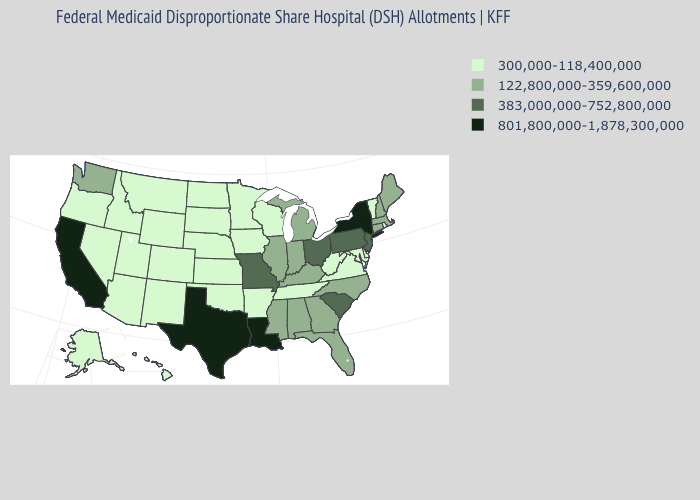Name the states that have a value in the range 122,800,000-359,600,000?
Be succinct. Alabama, Connecticut, Florida, Georgia, Illinois, Indiana, Kentucky, Maine, Massachusetts, Michigan, Mississippi, New Hampshire, North Carolina, Washington. Name the states that have a value in the range 122,800,000-359,600,000?
Answer briefly. Alabama, Connecticut, Florida, Georgia, Illinois, Indiana, Kentucky, Maine, Massachusetts, Michigan, Mississippi, New Hampshire, North Carolina, Washington. Is the legend a continuous bar?
Give a very brief answer. No. Name the states that have a value in the range 122,800,000-359,600,000?
Answer briefly. Alabama, Connecticut, Florida, Georgia, Illinois, Indiana, Kentucky, Maine, Massachusetts, Michigan, Mississippi, New Hampshire, North Carolina, Washington. Name the states that have a value in the range 383,000,000-752,800,000?
Keep it brief. Missouri, New Jersey, Ohio, Pennsylvania, South Carolina. Does Washington have the lowest value in the USA?
Give a very brief answer. No. Name the states that have a value in the range 122,800,000-359,600,000?
Quick response, please. Alabama, Connecticut, Florida, Georgia, Illinois, Indiana, Kentucky, Maine, Massachusetts, Michigan, Mississippi, New Hampshire, North Carolina, Washington. Name the states that have a value in the range 122,800,000-359,600,000?
Short answer required. Alabama, Connecticut, Florida, Georgia, Illinois, Indiana, Kentucky, Maine, Massachusetts, Michigan, Mississippi, New Hampshire, North Carolina, Washington. What is the highest value in the USA?
Keep it brief. 801,800,000-1,878,300,000. What is the value of West Virginia?
Be succinct. 300,000-118,400,000. Which states have the lowest value in the USA?
Be succinct. Alaska, Arizona, Arkansas, Colorado, Delaware, Hawaii, Idaho, Iowa, Kansas, Maryland, Minnesota, Montana, Nebraska, Nevada, New Mexico, North Dakota, Oklahoma, Oregon, Rhode Island, South Dakota, Tennessee, Utah, Vermont, Virginia, West Virginia, Wisconsin, Wyoming. What is the value of Louisiana?
Be succinct. 801,800,000-1,878,300,000. What is the value of New Hampshire?
Concise answer only. 122,800,000-359,600,000. What is the value of Louisiana?
Concise answer only. 801,800,000-1,878,300,000. 